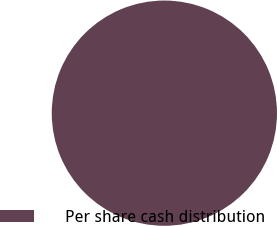Convert chart to OTSL. <chart><loc_0><loc_0><loc_500><loc_500><pie_chart><fcel>Per share cash distribution<nl><fcel>100.0%<nl></chart> 